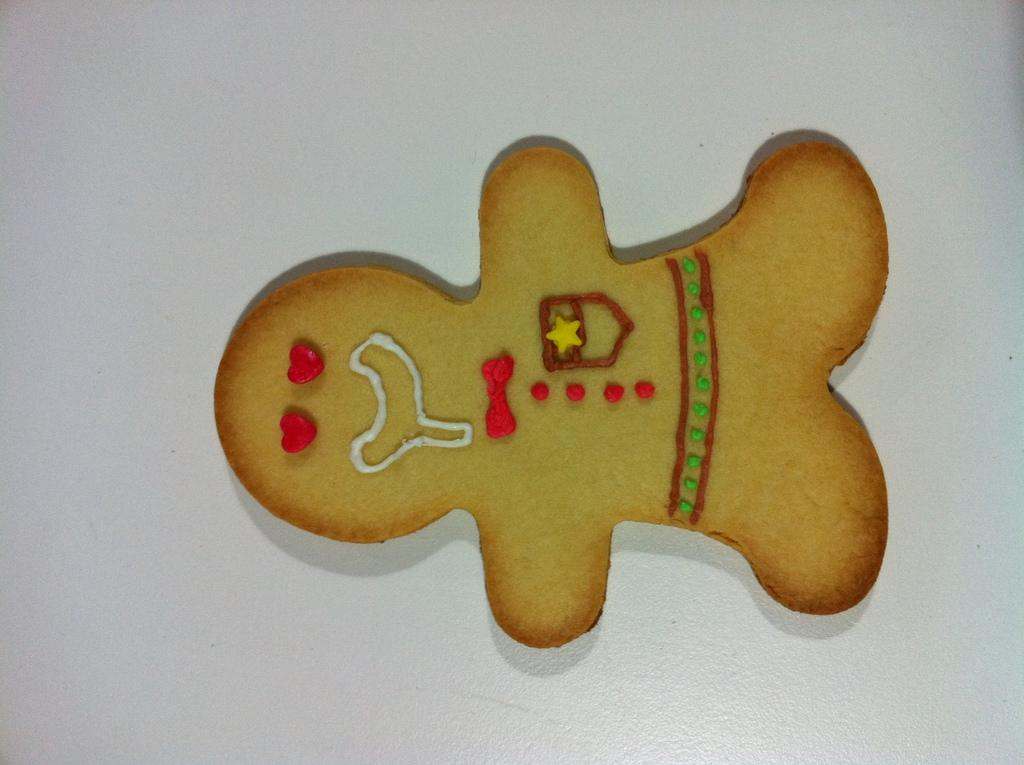What is the main subject of the image? There is a cookie in the image. What shape is the cookie? The cookie is in the shape of a toy. What colors can be seen on the cookie? The cookie has brown, red, green, and white colors. What is the background or surface on which the cookie is placed? The cookie is on a white surface. Can you see any pipes or mist in the image? No, there are no pipes or mist present in the image. Is there an iron visible in the image? No, there is no iron visible in the image. 